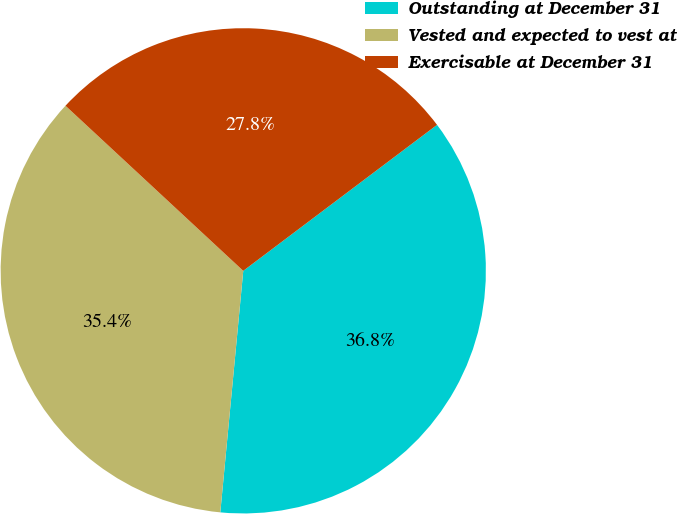Convert chart to OTSL. <chart><loc_0><loc_0><loc_500><loc_500><pie_chart><fcel>Outstanding at December 31<fcel>Vested and expected to vest at<fcel>Exercisable at December 31<nl><fcel>36.78%<fcel>35.4%<fcel>27.81%<nl></chart> 